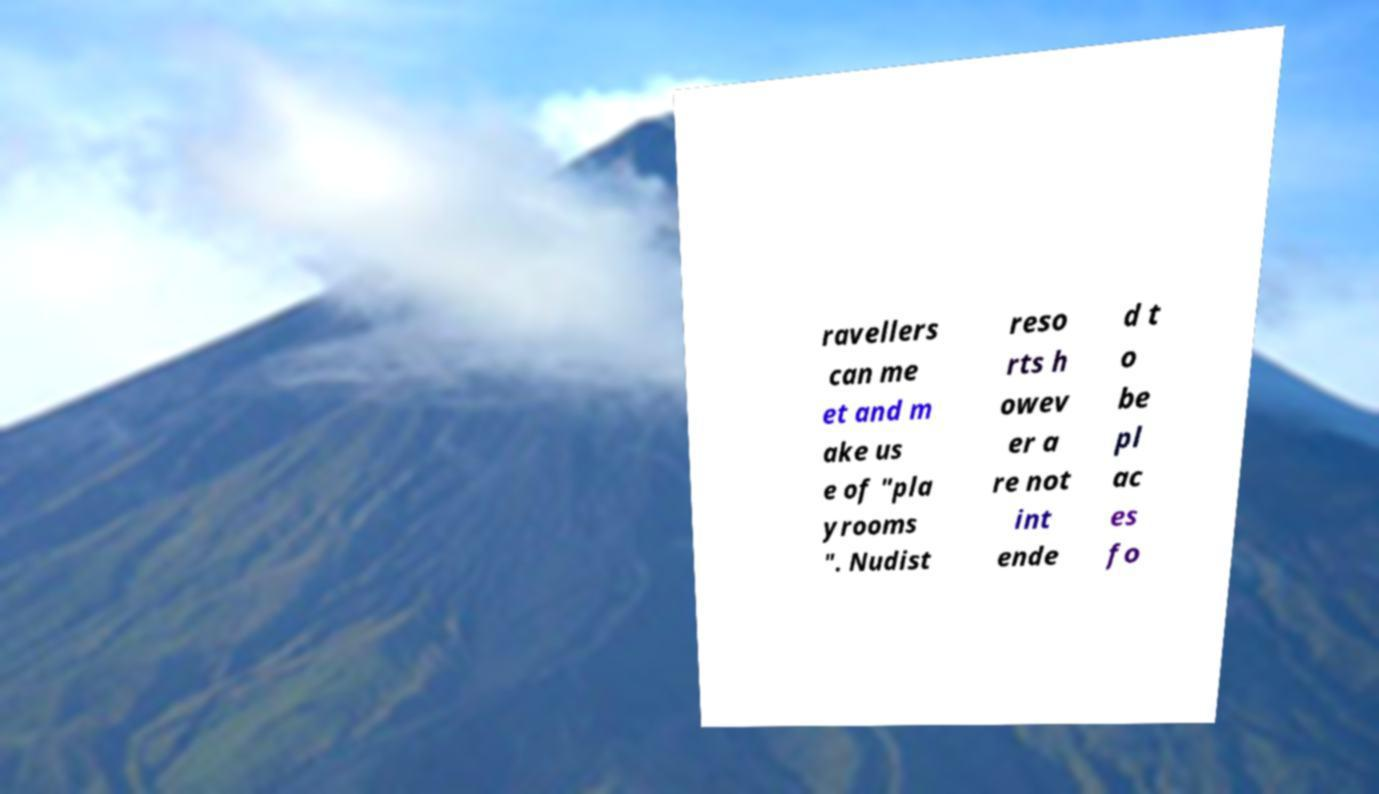There's text embedded in this image that I need extracted. Can you transcribe it verbatim? ravellers can me et and m ake us e of "pla yrooms ". Nudist reso rts h owev er a re not int ende d t o be pl ac es fo 